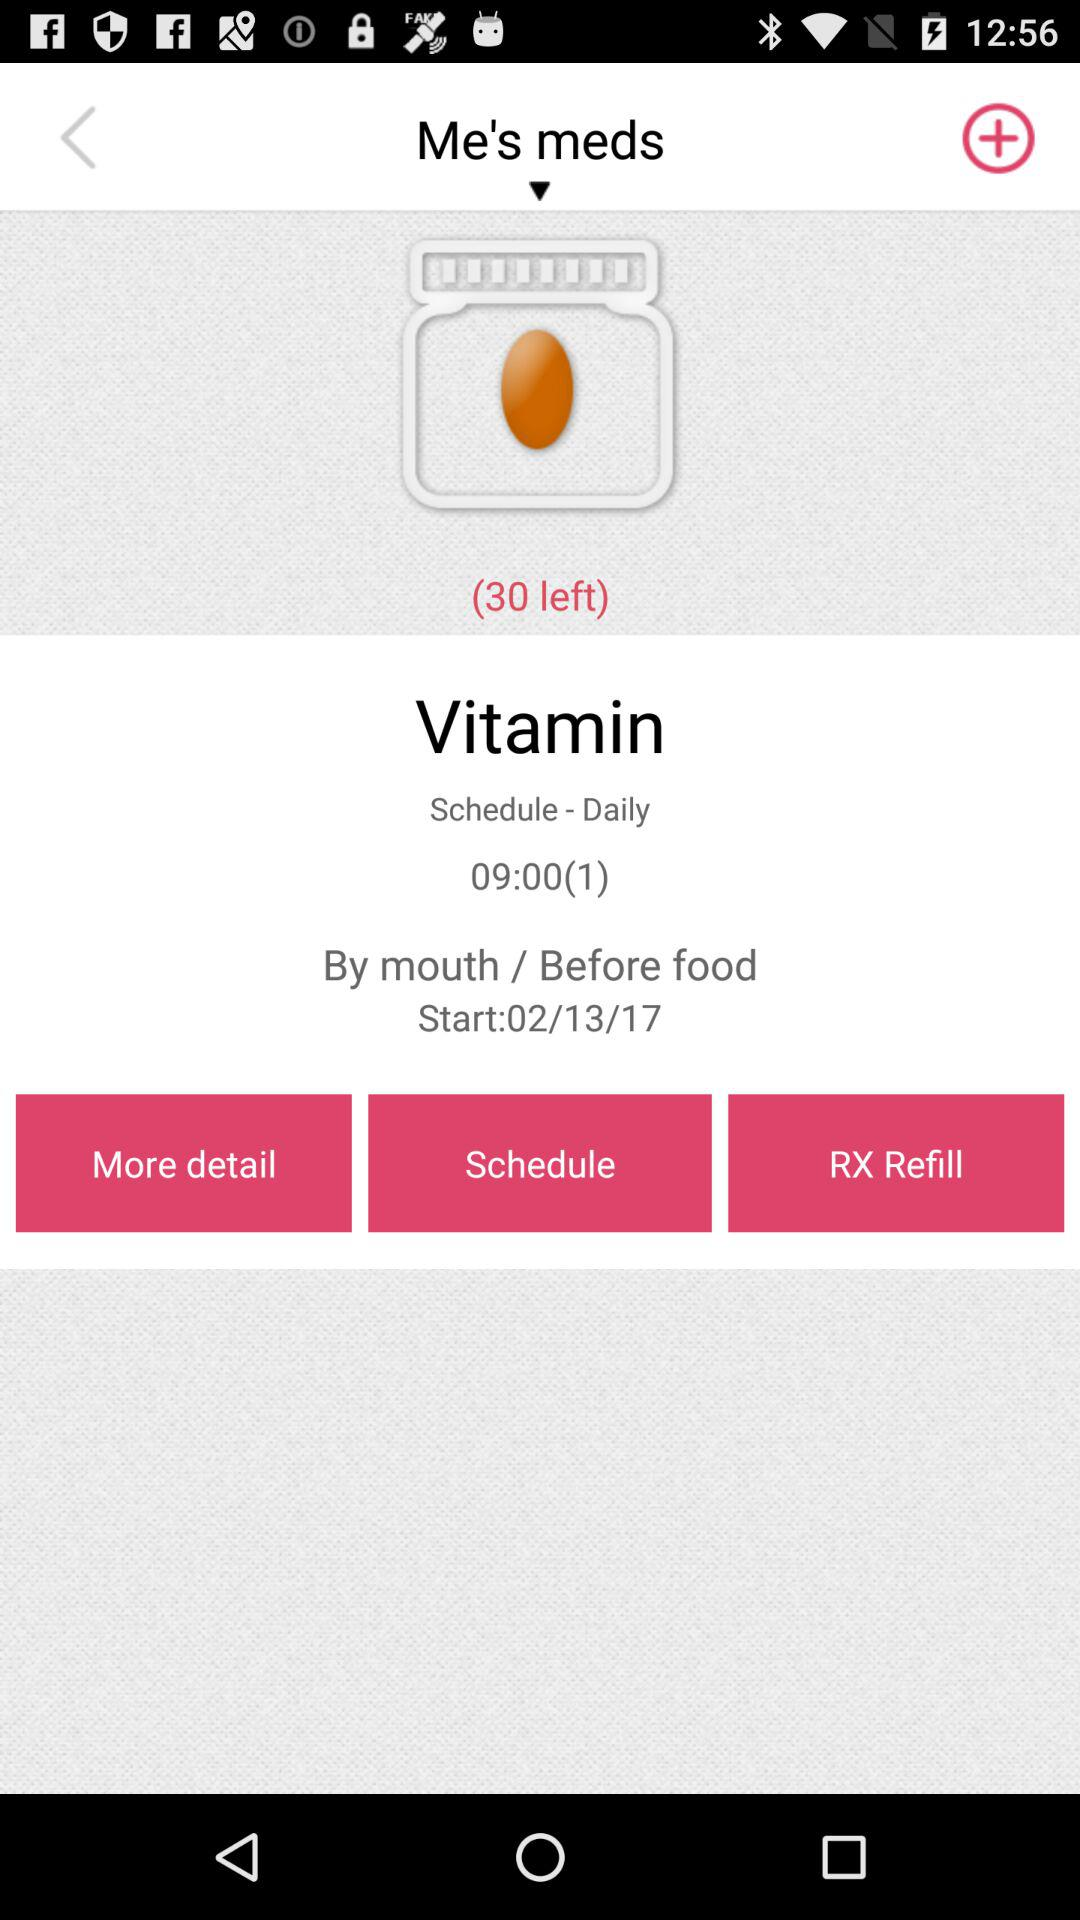What is the time? The time is 09:00(1). 